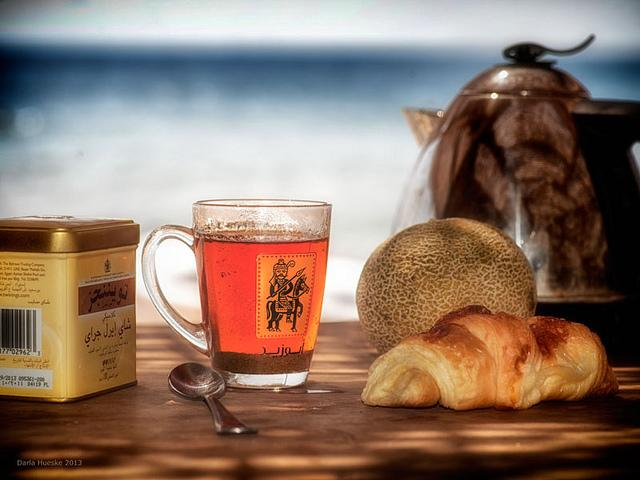What kind of beverage is there on the table top?

Choices:
A) beer
B) tea
C) juice
D) coffee tea 